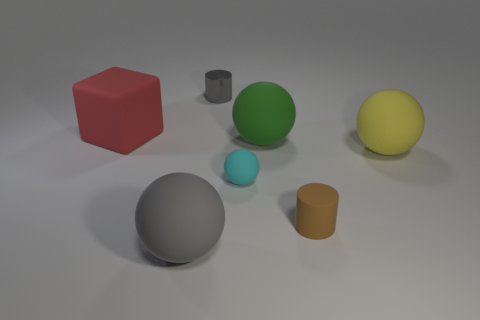What is the material of the big object to the left of the gray thing that is in front of the large yellow ball?
Give a very brief answer. Rubber. Is the number of cyan matte spheres behind the yellow object the same as the number of gray cylinders that are behind the shiny thing?
Provide a short and direct response. Yes. Is the cyan thing the same shape as the large yellow matte thing?
Make the answer very short. Yes. What material is the thing that is right of the gray matte thing and on the left side of the cyan rubber object?
Your answer should be compact. Metal. How many other big green matte things have the same shape as the green rubber thing?
Your answer should be very brief. 0. What is the size of the cylinder that is behind the yellow matte sphere that is in front of the cylinder left of the small brown object?
Offer a very short reply. Small. Is the number of large gray balls that are to the right of the red rubber object greater than the number of tiny green spheres?
Offer a terse response. Yes. Are any large yellow blocks visible?
Offer a very short reply. No. How many gray cubes are the same size as the gray ball?
Keep it short and to the point. 0. Are there more rubber things that are to the right of the red object than gray matte things that are to the right of the small sphere?
Your answer should be compact. Yes. 